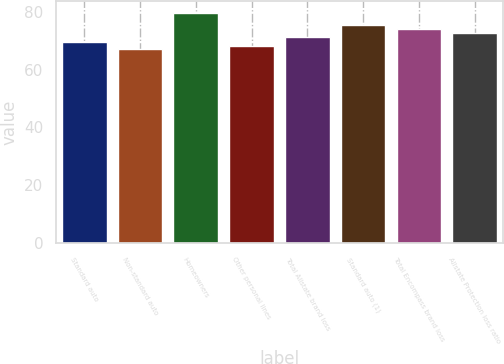Convert chart to OTSL. <chart><loc_0><loc_0><loc_500><loc_500><bar_chart><fcel>Standard auto<fcel>Non-standard auto<fcel>Homeowners<fcel>Other personal lines<fcel>Total Allstate brand loss<fcel>Standard auto (1)<fcel>Total Encompass brand loss<fcel>Allstate Protection loss ratio<nl><fcel>69.6<fcel>67.1<fcel>79.6<fcel>68.35<fcel>71.4<fcel>75.4<fcel>73.9<fcel>72.65<nl></chart> 